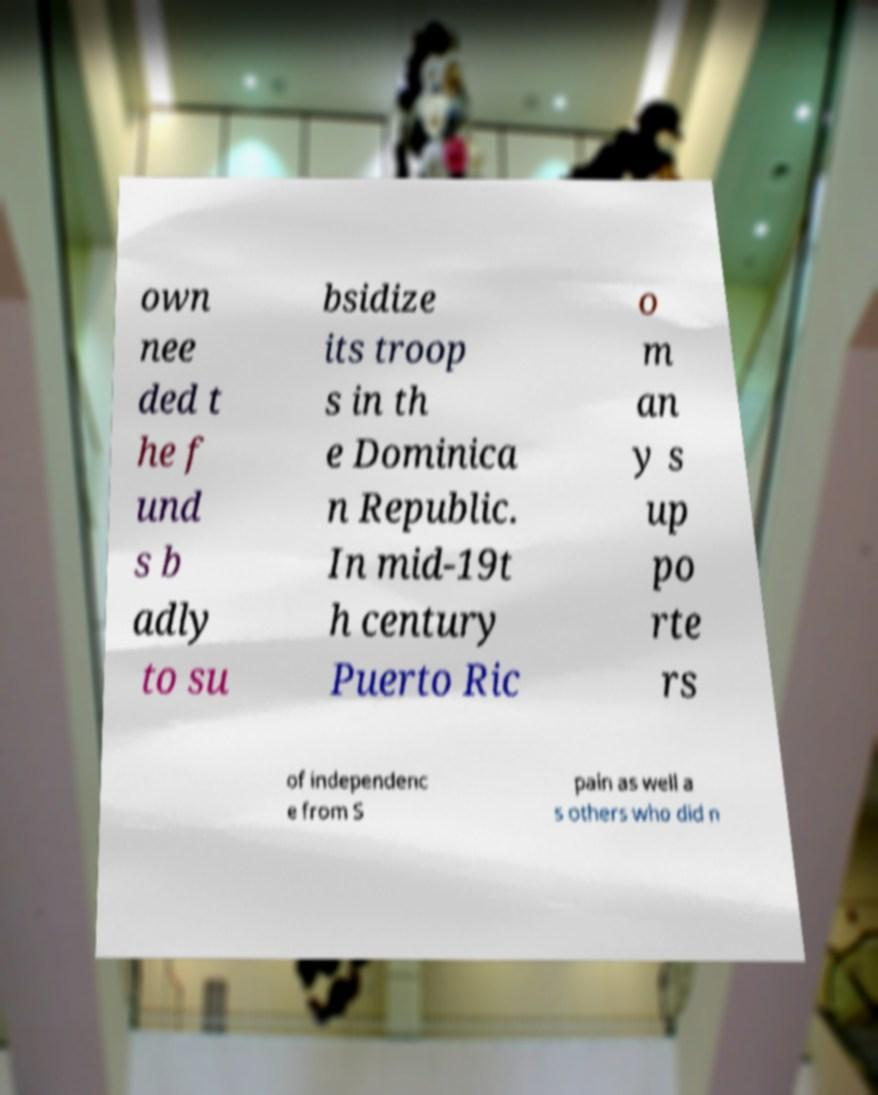I need the written content from this picture converted into text. Can you do that? own nee ded t he f und s b adly to su bsidize its troop s in th e Dominica n Republic. In mid-19t h century Puerto Ric o m an y s up po rte rs of independenc e from S pain as well a s others who did n 